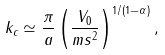<formula> <loc_0><loc_0><loc_500><loc_500>k _ { c } \simeq \frac { \pi } { a } \left ( \frac { V _ { 0 } } { m s ^ { 2 } } \right ) ^ { 1 / ( 1 - \alpha ) } ,</formula> 